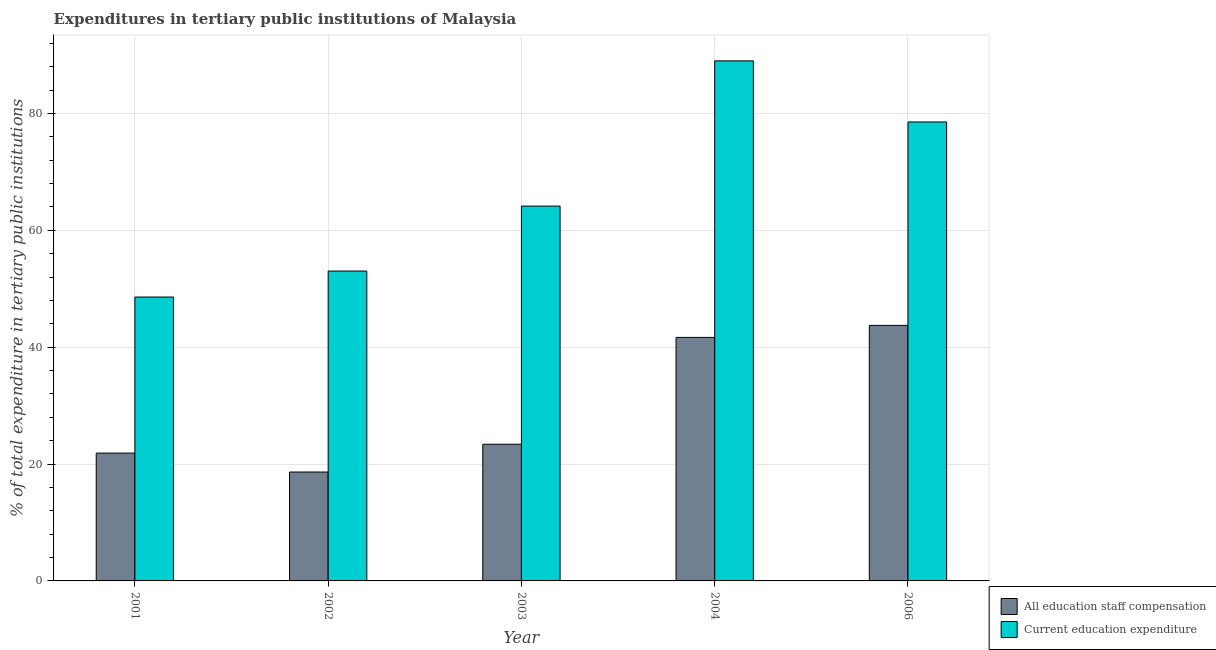How many different coloured bars are there?
Keep it short and to the point. 2. How many groups of bars are there?
Your answer should be very brief. 5. Are the number of bars per tick equal to the number of legend labels?
Provide a short and direct response. Yes. Are the number of bars on each tick of the X-axis equal?
Your response must be concise. Yes. How many bars are there on the 5th tick from the left?
Ensure brevity in your answer.  2. In how many cases, is the number of bars for a given year not equal to the number of legend labels?
Your answer should be very brief. 0. What is the expenditure in education in 2002?
Make the answer very short. 53.03. Across all years, what is the maximum expenditure in staff compensation?
Offer a terse response. 43.73. Across all years, what is the minimum expenditure in education?
Offer a terse response. 48.59. In which year was the expenditure in education maximum?
Your answer should be compact. 2004. In which year was the expenditure in staff compensation minimum?
Give a very brief answer. 2002. What is the total expenditure in education in the graph?
Provide a succinct answer. 333.32. What is the difference between the expenditure in education in 2001 and that in 2004?
Give a very brief answer. -40.42. What is the difference between the expenditure in staff compensation in 2003 and the expenditure in education in 2002?
Provide a short and direct response. 4.76. What is the average expenditure in education per year?
Offer a terse response. 66.66. What is the ratio of the expenditure in staff compensation in 2003 to that in 2006?
Ensure brevity in your answer.  0.53. Is the difference between the expenditure in staff compensation in 2002 and 2003 greater than the difference between the expenditure in education in 2002 and 2003?
Your response must be concise. No. What is the difference between the highest and the second highest expenditure in staff compensation?
Offer a terse response. 2.05. What is the difference between the highest and the lowest expenditure in staff compensation?
Give a very brief answer. 25.1. In how many years, is the expenditure in staff compensation greater than the average expenditure in staff compensation taken over all years?
Your answer should be very brief. 2. Is the sum of the expenditure in education in 2002 and 2006 greater than the maximum expenditure in staff compensation across all years?
Provide a succinct answer. Yes. What does the 1st bar from the left in 2001 represents?
Provide a short and direct response. All education staff compensation. What does the 1st bar from the right in 2004 represents?
Ensure brevity in your answer.  Current education expenditure. Are all the bars in the graph horizontal?
Your answer should be compact. No. What is the difference between two consecutive major ticks on the Y-axis?
Keep it short and to the point. 20. Are the values on the major ticks of Y-axis written in scientific E-notation?
Your answer should be compact. No. Where does the legend appear in the graph?
Your answer should be compact. Bottom right. How are the legend labels stacked?
Provide a succinct answer. Vertical. What is the title of the graph?
Ensure brevity in your answer.  Expenditures in tertiary public institutions of Malaysia. What is the label or title of the Y-axis?
Make the answer very short. % of total expenditure in tertiary public institutions. What is the % of total expenditure in tertiary public institutions of All education staff compensation in 2001?
Your response must be concise. 21.88. What is the % of total expenditure in tertiary public institutions of Current education expenditure in 2001?
Provide a succinct answer. 48.59. What is the % of total expenditure in tertiary public institutions in All education staff compensation in 2002?
Provide a succinct answer. 18.64. What is the % of total expenditure in tertiary public institutions in Current education expenditure in 2002?
Make the answer very short. 53.03. What is the % of total expenditure in tertiary public institutions of All education staff compensation in 2003?
Make the answer very short. 23.4. What is the % of total expenditure in tertiary public institutions of Current education expenditure in 2003?
Your answer should be very brief. 64.15. What is the % of total expenditure in tertiary public institutions of All education staff compensation in 2004?
Offer a terse response. 41.68. What is the % of total expenditure in tertiary public institutions of Current education expenditure in 2004?
Your answer should be compact. 89. What is the % of total expenditure in tertiary public institutions in All education staff compensation in 2006?
Your answer should be compact. 43.73. What is the % of total expenditure in tertiary public institutions of Current education expenditure in 2006?
Provide a succinct answer. 78.55. Across all years, what is the maximum % of total expenditure in tertiary public institutions of All education staff compensation?
Your answer should be very brief. 43.73. Across all years, what is the maximum % of total expenditure in tertiary public institutions in Current education expenditure?
Provide a short and direct response. 89. Across all years, what is the minimum % of total expenditure in tertiary public institutions in All education staff compensation?
Offer a terse response. 18.64. Across all years, what is the minimum % of total expenditure in tertiary public institutions of Current education expenditure?
Provide a short and direct response. 48.59. What is the total % of total expenditure in tertiary public institutions of All education staff compensation in the graph?
Your response must be concise. 149.33. What is the total % of total expenditure in tertiary public institutions of Current education expenditure in the graph?
Your answer should be very brief. 333.32. What is the difference between the % of total expenditure in tertiary public institutions in All education staff compensation in 2001 and that in 2002?
Make the answer very short. 3.24. What is the difference between the % of total expenditure in tertiary public institutions of Current education expenditure in 2001 and that in 2002?
Ensure brevity in your answer.  -4.45. What is the difference between the % of total expenditure in tertiary public institutions of All education staff compensation in 2001 and that in 2003?
Your answer should be compact. -1.52. What is the difference between the % of total expenditure in tertiary public institutions in Current education expenditure in 2001 and that in 2003?
Keep it short and to the point. -15.56. What is the difference between the % of total expenditure in tertiary public institutions in All education staff compensation in 2001 and that in 2004?
Your answer should be compact. -19.8. What is the difference between the % of total expenditure in tertiary public institutions in Current education expenditure in 2001 and that in 2004?
Make the answer very short. -40.42. What is the difference between the % of total expenditure in tertiary public institutions of All education staff compensation in 2001 and that in 2006?
Your answer should be very brief. -21.86. What is the difference between the % of total expenditure in tertiary public institutions of Current education expenditure in 2001 and that in 2006?
Keep it short and to the point. -29.96. What is the difference between the % of total expenditure in tertiary public institutions of All education staff compensation in 2002 and that in 2003?
Your response must be concise. -4.76. What is the difference between the % of total expenditure in tertiary public institutions in Current education expenditure in 2002 and that in 2003?
Offer a very short reply. -11.12. What is the difference between the % of total expenditure in tertiary public institutions in All education staff compensation in 2002 and that in 2004?
Provide a short and direct response. -23.04. What is the difference between the % of total expenditure in tertiary public institutions in Current education expenditure in 2002 and that in 2004?
Offer a terse response. -35.97. What is the difference between the % of total expenditure in tertiary public institutions in All education staff compensation in 2002 and that in 2006?
Provide a succinct answer. -25.1. What is the difference between the % of total expenditure in tertiary public institutions of Current education expenditure in 2002 and that in 2006?
Offer a terse response. -25.51. What is the difference between the % of total expenditure in tertiary public institutions in All education staff compensation in 2003 and that in 2004?
Your answer should be very brief. -18.28. What is the difference between the % of total expenditure in tertiary public institutions in Current education expenditure in 2003 and that in 2004?
Your answer should be very brief. -24.85. What is the difference between the % of total expenditure in tertiary public institutions in All education staff compensation in 2003 and that in 2006?
Your response must be concise. -20.34. What is the difference between the % of total expenditure in tertiary public institutions of Current education expenditure in 2003 and that in 2006?
Make the answer very short. -14.4. What is the difference between the % of total expenditure in tertiary public institutions of All education staff compensation in 2004 and that in 2006?
Provide a short and direct response. -2.05. What is the difference between the % of total expenditure in tertiary public institutions in Current education expenditure in 2004 and that in 2006?
Your response must be concise. 10.46. What is the difference between the % of total expenditure in tertiary public institutions of All education staff compensation in 2001 and the % of total expenditure in tertiary public institutions of Current education expenditure in 2002?
Your answer should be compact. -31.15. What is the difference between the % of total expenditure in tertiary public institutions of All education staff compensation in 2001 and the % of total expenditure in tertiary public institutions of Current education expenditure in 2003?
Offer a very short reply. -42.27. What is the difference between the % of total expenditure in tertiary public institutions of All education staff compensation in 2001 and the % of total expenditure in tertiary public institutions of Current education expenditure in 2004?
Your answer should be very brief. -67.12. What is the difference between the % of total expenditure in tertiary public institutions of All education staff compensation in 2001 and the % of total expenditure in tertiary public institutions of Current education expenditure in 2006?
Ensure brevity in your answer.  -56.67. What is the difference between the % of total expenditure in tertiary public institutions in All education staff compensation in 2002 and the % of total expenditure in tertiary public institutions in Current education expenditure in 2003?
Give a very brief answer. -45.51. What is the difference between the % of total expenditure in tertiary public institutions in All education staff compensation in 2002 and the % of total expenditure in tertiary public institutions in Current education expenditure in 2004?
Your answer should be very brief. -70.37. What is the difference between the % of total expenditure in tertiary public institutions in All education staff compensation in 2002 and the % of total expenditure in tertiary public institutions in Current education expenditure in 2006?
Provide a succinct answer. -59.91. What is the difference between the % of total expenditure in tertiary public institutions in All education staff compensation in 2003 and the % of total expenditure in tertiary public institutions in Current education expenditure in 2004?
Ensure brevity in your answer.  -65.61. What is the difference between the % of total expenditure in tertiary public institutions in All education staff compensation in 2003 and the % of total expenditure in tertiary public institutions in Current education expenditure in 2006?
Keep it short and to the point. -55.15. What is the difference between the % of total expenditure in tertiary public institutions in All education staff compensation in 2004 and the % of total expenditure in tertiary public institutions in Current education expenditure in 2006?
Your response must be concise. -36.87. What is the average % of total expenditure in tertiary public institutions of All education staff compensation per year?
Offer a very short reply. 29.86. What is the average % of total expenditure in tertiary public institutions in Current education expenditure per year?
Give a very brief answer. 66.66. In the year 2001, what is the difference between the % of total expenditure in tertiary public institutions in All education staff compensation and % of total expenditure in tertiary public institutions in Current education expenditure?
Your answer should be very brief. -26.71. In the year 2002, what is the difference between the % of total expenditure in tertiary public institutions of All education staff compensation and % of total expenditure in tertiary public institutions of Current education expenditure?
Keep it short and to the point. -34.4. In the year 2003, what is the difference between the % of total expenditure in tertiary public institutions in All education staff compensation and % of total expenditure in tertiary public institutions in Current education expenditure?
Provide a short and direct response. -40.76. In the year 2004, what is the difference between the % of total expenditure in tertiary public institutions in All education staff compensation and % of total expenditure in tertiary public institutions in Current education expenditure?
Ensure brevity in your answer.  -47.32. In the year 2006, what is the difference between the % of total expenditure in tertiary public institutions in All education staff compensation and % of total expenditure in tertiary public institutions in Current education expenditure?
Your answer should be compact. -34.81. What is the ratio of the % of total expenditure in tertiary public institutions of All education staff compensation in 2001 to that in 2002?
Your answer should be compact. 1.17. What is the ratio of the % of total expenditure in tertiary public institutions in Current education expenditure in 2001 to that in 2002?
Your answer should be very brief. 0.92. What is the ratio of the % of total expenditure in tertiary public institutions of All education staff compensation in 2001 to that in 2003?
Make the answer very short. 0.94. What is the ratio of the % of total expenditure in tertiary public institutions of Current education expenditure in 2001 to that in 2003?
Offer a terse response. 0.76. What is the ratio of the % of total expenditure in tertiary public institutions in All education staff compensation in 2001 to that in 2004?
Provide a short and direct response. 0.52. What is the ratio of the % of total expenditure in tertiary public institutions of Current education expenditure in 2001 to that in 2004?
Provide a succinct answer. 0.55. What is the ratio of the % of total expenditure in tertiary public institutions of All education staff compensation in 2001 to that in 2006?
Your answer should be compact. 0.5. What is the ratio of the % of total expenditure in tertiary public institutions in Current education expenditure in 2001 to that in 2006?
Keep it short and to the point. 0.62. What is the ratio of the % of total expenditure in tertiary public institutions of All education staff compensation in 2002 to that in 2003?
Your answer should be very brief. 0.8. What is the ratio of the % of total expenditure in tertiary public institutions in Current education expenditure in 2002 to that in 2003?
Keep it short and to the point. 0.83. What is the ratio of the % of total expenditure in tertiary public institutions in All education staff compensation in 2002 to that in 2004?
Ensure brevity in your answer.  0.45. What is the ratio of the % of total expenditure in tertiary public institutions of Current education expenditure in 2002 to that in 2004?
Keep it short and to the point. 0.6. What is the ratio of the % of total expenditure in tertiary public institutions in All education staff compensation in 2002 to that in 2006?
Offer a very short reply. 0.43. What is the ratio of the % of total expenditure in tertiary public institutions of Current education expenditure in 2002 to that in 2006?
Keep it short and to the point. 0.68. What is the ratio of the % of total expenditure in tertiary public institutions of All education staff compensation in 2003 to that in 2004?
Provide a succinct answer. 0.56. What is the ratio of the % of total expenditure in tertiary public institutions in Current education expenditure in 2003 to that in 2004?
Your response must be concise. 0.72. What is the ratio of the % of total expenditure in tertiary public institutions of All education staff compensation in 2003 to that in 2006?
Make the answer very short. 0.53. What is the ratio of the % of total expenditure in tertiary public institutions of Current education expenditure in 2003 to that in 2006?
Make the answer very short. 0.82. What is the ratio of the % of total expenditure in tertiary public institutions in All education staff compensation in 2004 to that in 2006?
Ensure brevity in your answer.  0.95. What is the ratio of the % of total expenditure in tertiary public institutions in Current education expenditure in 2004 to that in 2006?
Your response must be concise. 1.13. What is the difference between the highest and the second highest % of total expenditure in tertiary public institutions of All education staff compensation?
Ensure brevity in your answer.  2.05. What is the difference between the highest and the second highest % of total expenditure in tertiary public institutions in Current education expenditure?
Offer a very short reply. 10.46. What is the difference between the highest and the lowest % of total expenditure in tertiary public institutions in All education staff compensation?
Ensure brevity in your answer.  25.1. What is the difference between the highest and the lowest % of total expenditure in tertiary public institutions of Current education expenditure?
Offer a terse response. 40.42. 